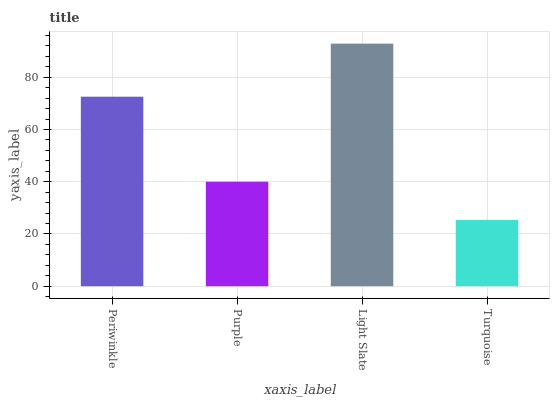Is Turquoise the minimum?
Answer yes or no. Yes. Is Light Slate the maximum?
Answer yes or no. Yes. Is Purple the minimum?
Answer yes or no. No. Is Purple the maximum?
Answer yes or no. No. Is Periwinkle greater than Purple?
Answer yes or no. Yes. Is Purple less than Periwinkle?
Answer yes or no. Yes. Is Purple greater than Periwinkle?
Answer yes or no. No. Is Periwinkle less than Purple?
Answer yes or no. No. Is Periwinkle the high median?
Answer yes or no. Yes. Is Purple the low median?
Answer yes or no. Yes. Is Light Slate the high median?
Answer yes or no. No. Is Light Slate the low median?
Answer yes or no. No. 